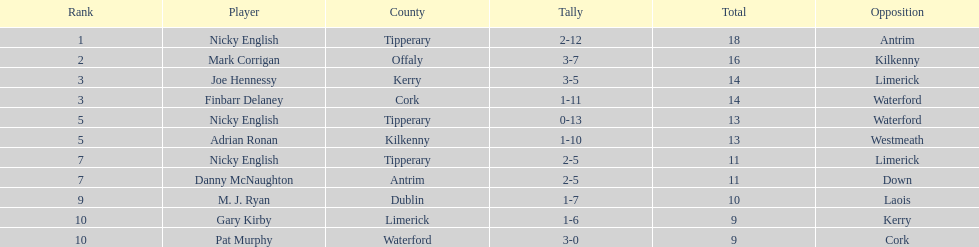Who ranked above mark corrigan? Nicky English. 